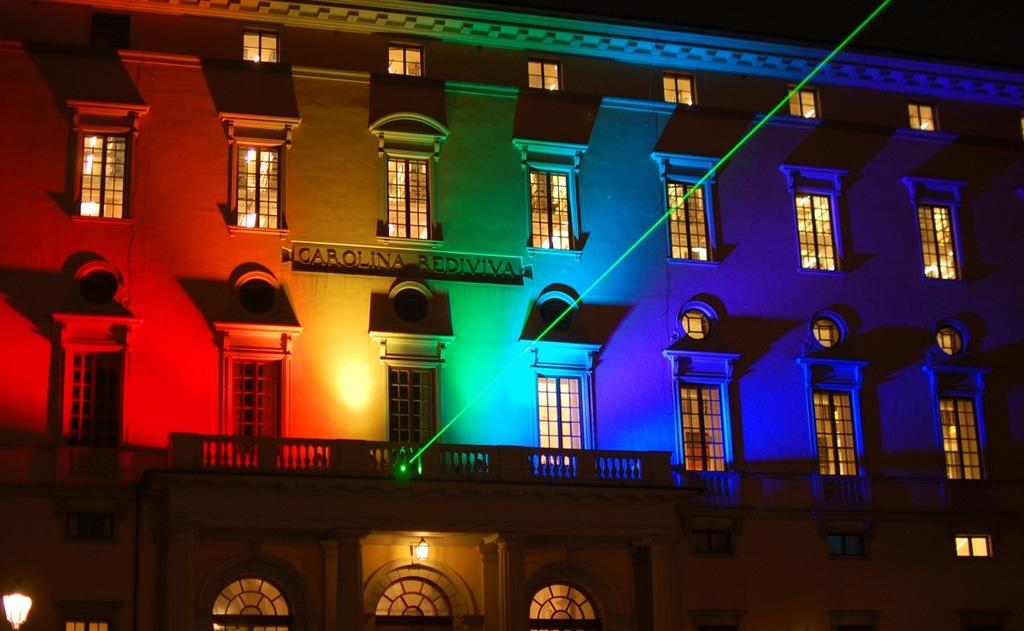What type of structure is present in the image? There is a building in the image. What are some notable features of the building? The building has many windows and railing. Are there any additional elements attached to the building? Yes, there are lights attached to the building. What can be observed about the background of the image? The background of the image is black. What type of scent can be detected coming from the building in the image? There is no indication of a scent in the image, as it only shows a building with windows, railing, and lights. 